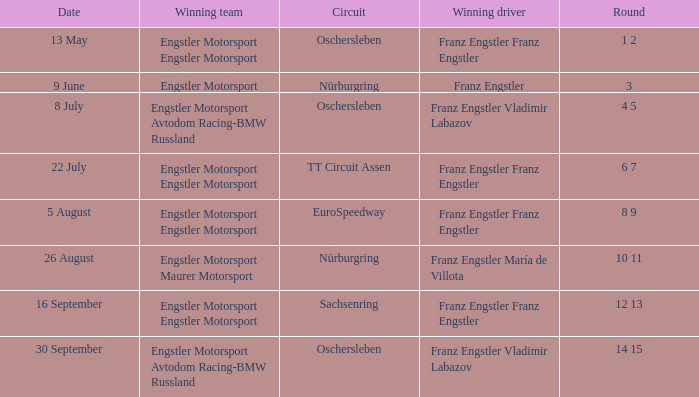With a Date of 22 July, what is the Winning team? Engstler Motorsport Engstler Motorsport. 